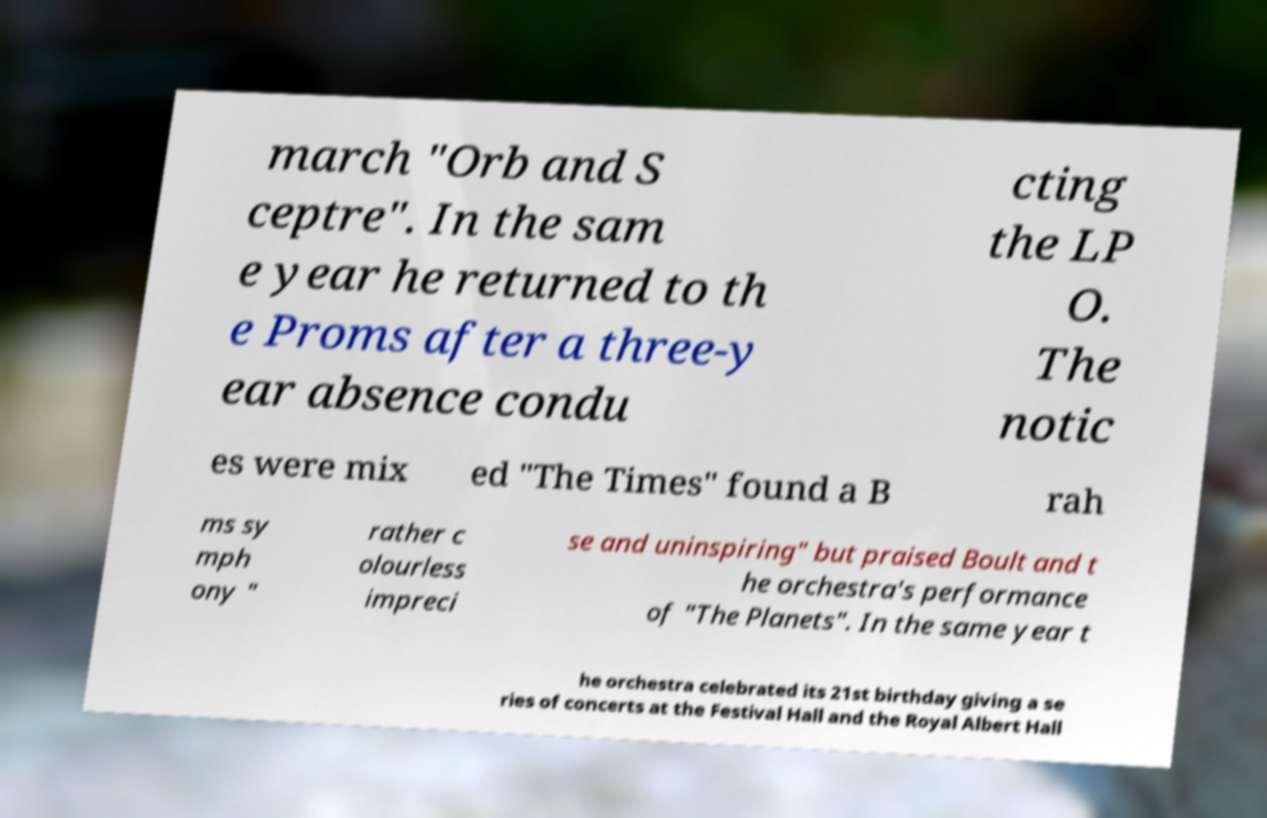Can you accurately transcribe the text from the provided image for me? march "Orb and S ceptre". In the sam e year he returned to th e Proms after a three-y ear absence condu cting the LP O. The notic es were mix ed "The Times" found a B rah ms sy mph ony " rather c olourless impreci se and uninspiring" but praised Boult and t he orchestra's performance of "The Planets". In the same year t he orchestra celebrated its 21st birthday giving a se ries of concerts at the Festival Hall and the Royal Albert Hall 